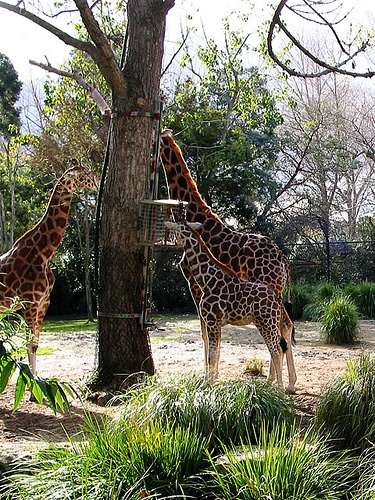Describe the objects in this image and their specific colors. I can see giraffe in white, black, gray, and maroon tones, giraffe in white, black, maroon, and gray tones, and giraffe in white, black, maroon, and gray tones in this image. 